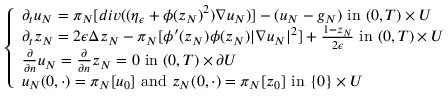<formula> <loc_0><loc_0><loc_500><loc_500>\left \{ \begin{array} { l l } { \partial _ { t } u _ { N } = \pi _ { N } [ d i v ( ( \eta _ { \epsilon } + \phi ( z _ { N } ) ^ { 2 } ) \nabla u _ { N } ) ] - ( u _ { N } - g _ { N } ) i n ( 0 , T ) \times U } \\ { \partial _ { t } z _ { N } = 2 \epsilon \Delta z _ { N } - \pi _ { N } [ \phi ^ { \prime } ( z _ { N } ) \phi ( z _ { N } ) | \nabla u _ { N } | ^ { 2 } ] + \frac { 1 - z _ { N } } { 2 \epsilon } i n ( 0 , T ) \times U } \\ { \frac { \partial } { \partial n } u _ { N } = \frac { \partial } { \partial n } z _ { N } = 0 i n ( 0 , T ) \times \partial U } \\ { u _ { N } ( 0 , \cdot ) = \pi _ { N } [ u _ { 0 } ] a n d z _ { N } ( 0 , \cdot ) = \pi _ { N } [ z _ { 0 } ] i n \{ 0 \} \times U } \end{array}</formula> 